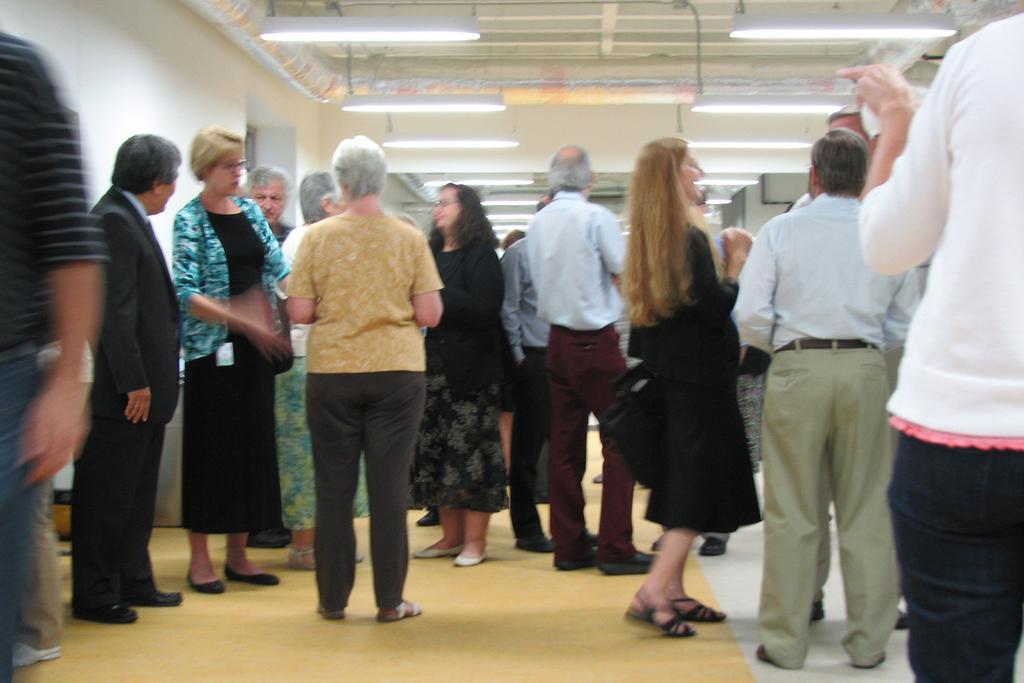Could you give a brief overview of what you see in this image? In the picture I can see a group of people standing on the floor. I can see a few of them having a conversation and a few of them are laughing. I can see the lighting arrangement on the roof. 